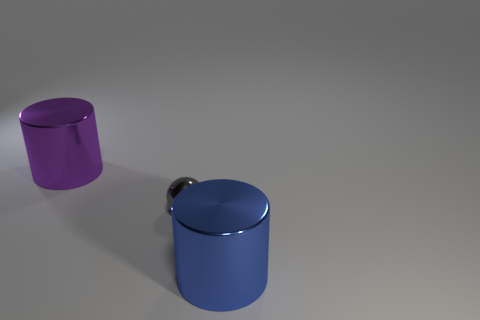Add 1 large shiny cylinders. How many objects exist? 4 Subtract all cylinders. How many objects are left? 1 Subtract 1 cylinders. How many cylinders are left? 1 Subtract all purple objects. Subtract all shiny balls. How many objects are left? 1 Add 1 large blue metallic cylinders. How many large blue metallic cylinders are left? 2 Add 2 yellow metallic objects. How many yellow metallic objects exist? 2 Subtract 1 purple cylinders. How many objects are left? 2 Subtract all green spheres. Subtract all yellow blocks. How many spheres are left? 1 